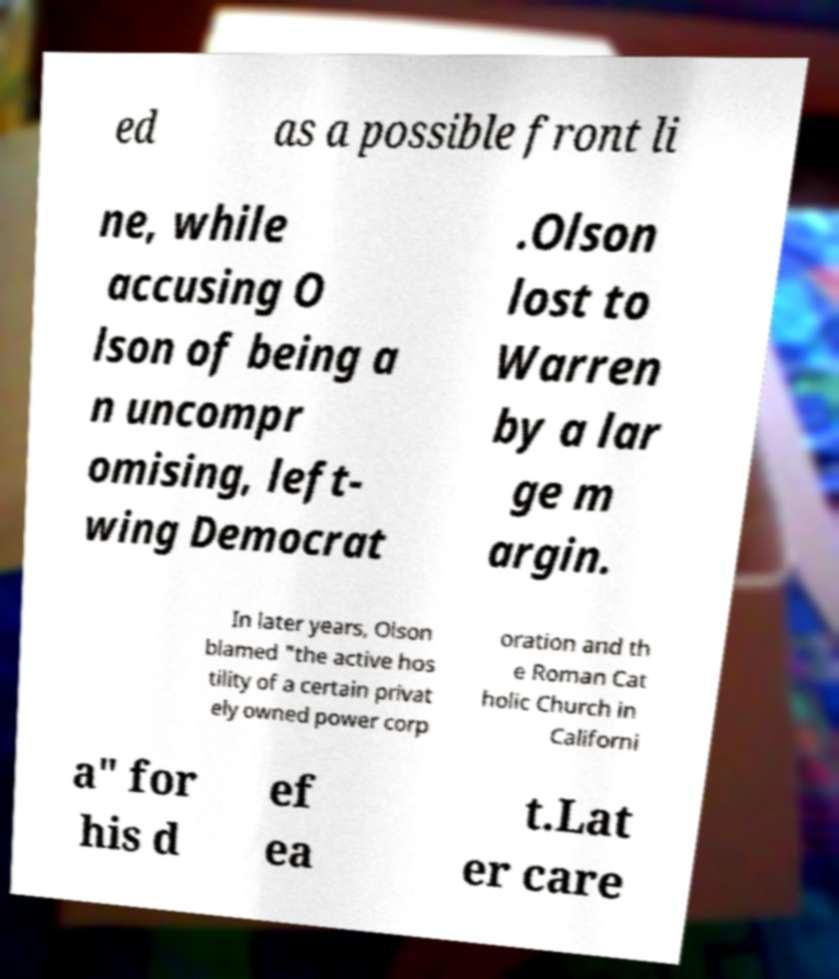There's text embedded in this image that I need extracted. Can you transcribe it verbatim? ed as a possible front li ne, while accusing O lson of being a n uncompr omising, left- wing Democrat .Olson lost to Warren by a lar ge m argin. In later years, Olson blamed "the active hos tility of a certain privat ely owned power corp oration and th e Roman Cat holic Church in Californi a" for his d ef ea t.Lat er care 